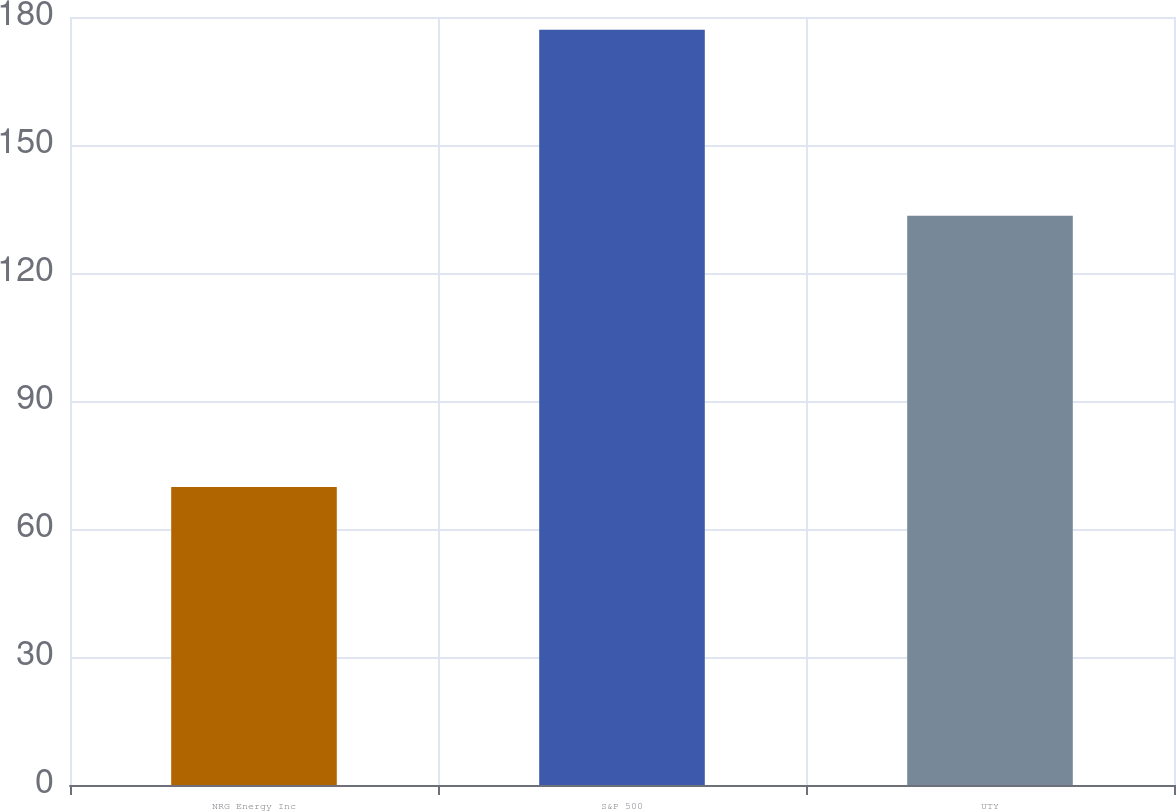Convert chart to OTSL. <chart><loc_0><loc_0><loc_500><loc_500><bar_chart><fcel>NRG Energy Inc<fcel>S&P 500<fcel>UTY<nl><fcel>69.83<fcel>177.01<fcel>133.39<nl></chart> 